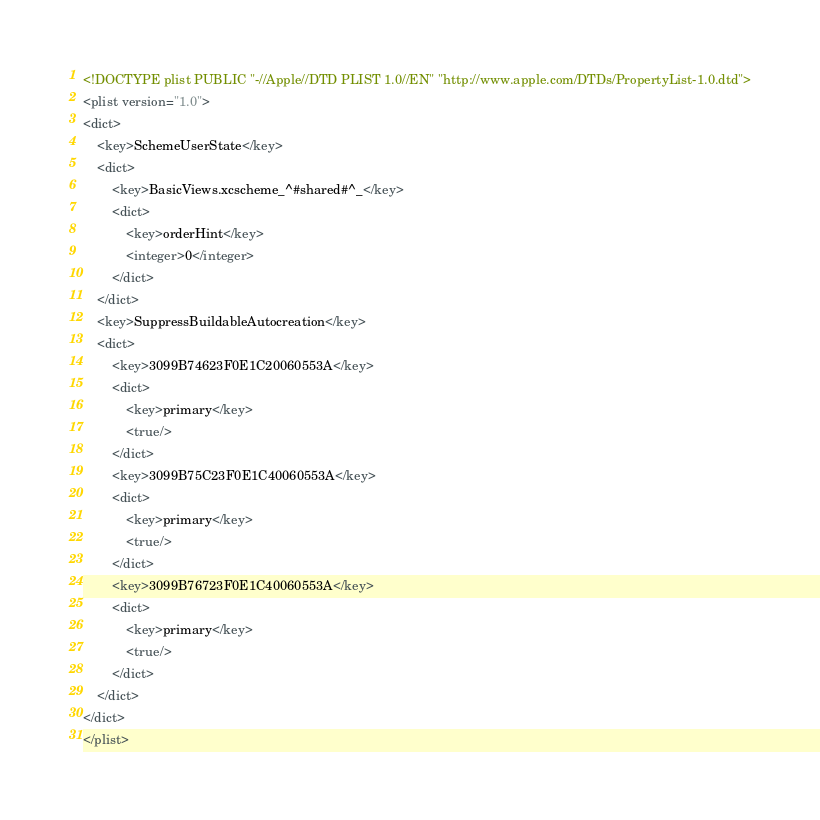Convert code to text. <code><loc_0><loc_0><loc_500><loc_500><_XML_><!DOCTYPE plist PUBLIC "-//Apple//DTD PLIST 1.0//EN" "http://www.apple.com/DTDs/PropertyList-1.0.dtd">
<plist version="1.0">
<dict>
	<key>SchemeUserState</key>
	<dict>
		<key>BasicViews.xcscheme_^#shared#^_</key>
		<dict>
			<key>orderHint</key>
			<integer>0</integer>
		</dict>
	</dict>
	<key>SuppressBuildableAutocreation</key>
	<dict>
		<key>3099B74623F0E1C20060553A</key>
		<dict>
			<key>primary</key>
			<true/>
		</dict>
		<key>3099B75C23F0E1C40060553A</key>
		<dict>
			<key>primary</key>
			<true/>
		</dict>
		<key>3099B76723F0E1C40060553A</key>
		<dict>
			<key>primary</key>
			<true/>
		</dict>
	</dict>
</dict>
</plist>
</code> 